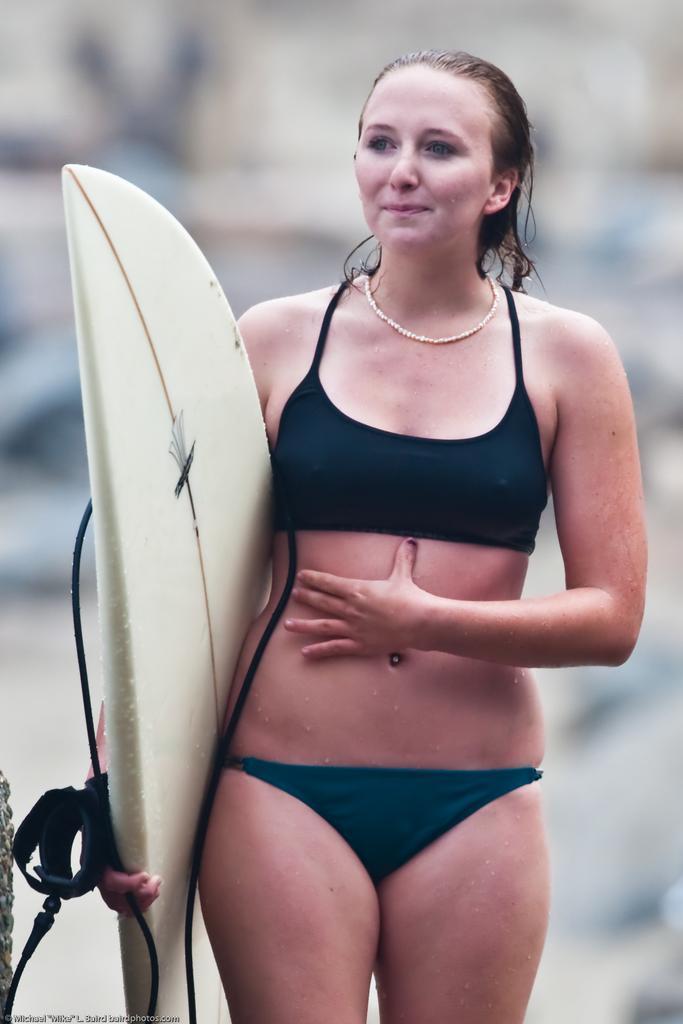Please provide a concise description of this image. a person is standing , holding a white color water skateboard in her hand. 